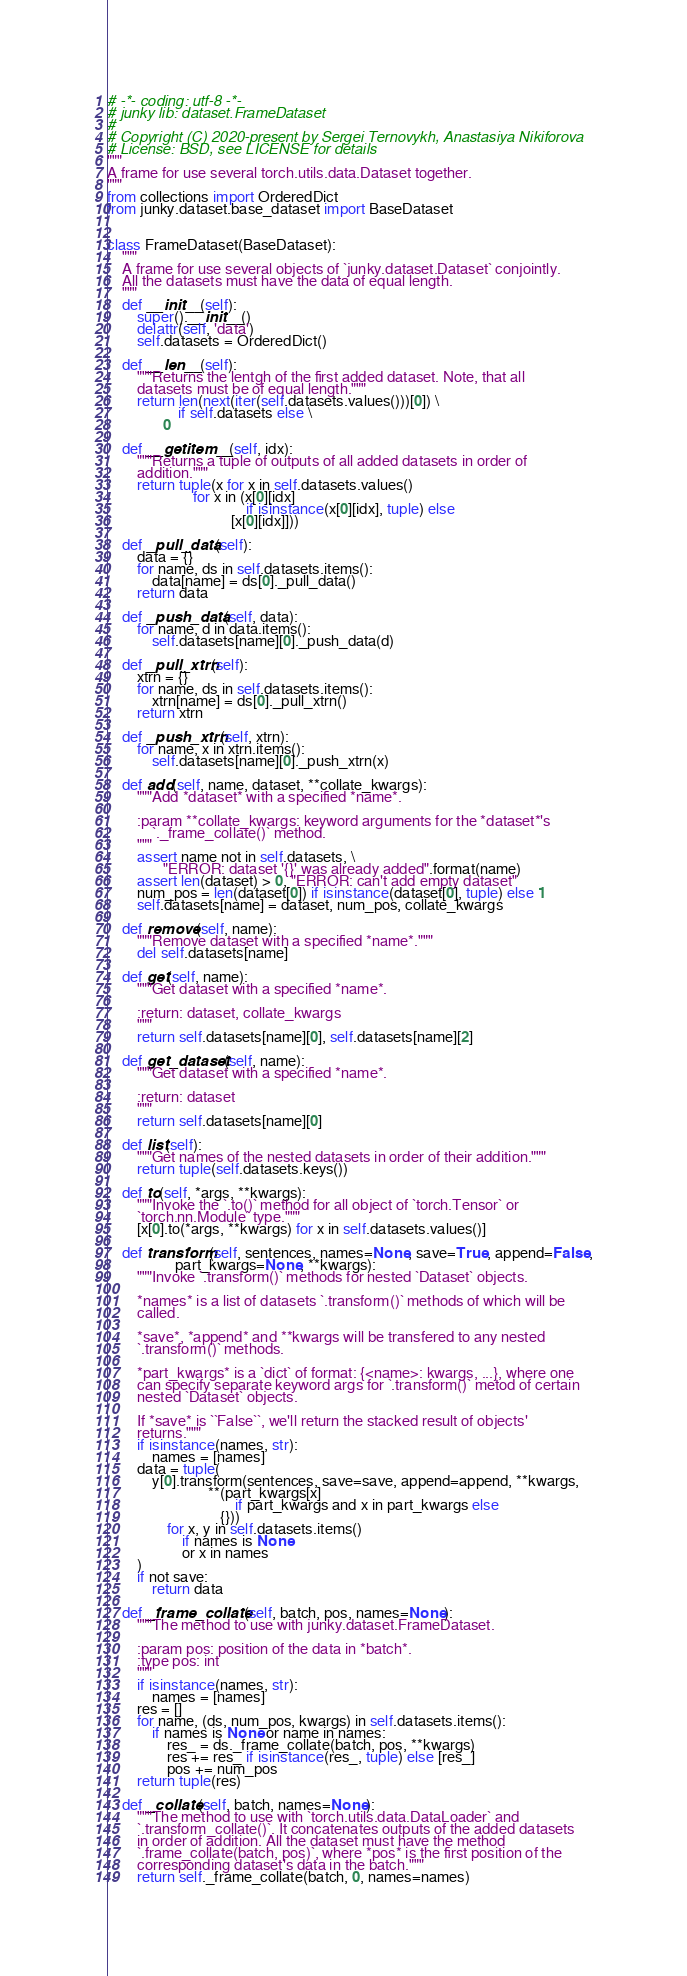<code> <loc_0><loc_0><loc_500><loc_500><_Python_># -*- coding: utf-8 -*-
# junky lib: dataset.FrameDataset
#
# Copyright (C) 2020-present by Sergei Ternovykh, Anastasiya Nikiforova
# License: BSD, see LICENSE for details
"""
A frame for use several torch.utils.data.Dataset together.
"""
from collections import OrderedDict
from junky.dataset.base_dataset import BaseDataset


class FrameDataset(BaseDataset):
    """
    A frame for use several objects of `junky.dataset.Dataset` conjointly.
    All the datasets must have the data of equal length.
    """
    def __init__(self):
        super().__init__()
        delattr(self, 'data')
        self.datasets = OrderedDict()

    def __len__(self):
        """Returns the lentgh of the first added dataset. Note, that all
        datasets must be of equal length."""
        return len(next(iter(self.datasets.values()))[0]) \
                   if self.datasets else \
               0

    def __getitem__(self, idx):
        """Returns a tuple of outputs of all added datasets in order of
        addition."""
        return tuple(x for x in self.datasets.values()
                       for x in (x[0][idx]
                                     if isinstance(x[0][idx], tuple) else
                                 [x[0][idx]]))

    def _pull_data(self):
        data = {}
        for name, ds in self.datasets.items():
            data[name] = ds[0]._pull_data()
        return data

    def _push_data(self, data):
        for name, d in data.items():
            self.datasets[name][0]._push_data(d)

    def _pull_xtrn(self):
        xtrn = {}
        for name, ds in self.datasets.items():
            xtrn[name] = ds[0]._pull_xtrn()
        return xtrn

    def _push_xtrn(self, xtrn):
        for name, x in xtrn.items():
            self.datasets[name][0]._push_xtrn(x)

    def add(self, name, dataset, **collate_kwargs):
        """Add *dataset* with a specified *name*.

        :param **collate_kwargs: keyword arguments for the *dataset*'s
            `._frame_collate()` method.
        """
        assert name not in self.datasets, \
               "ERROR: dataset '{}' was already added".format(name)
        assert len(dataset) > 0, "ERROR: can't add empty dataset"
        num_pos = len(dataset[0]) if isinstance(dataset[0], tuple) else 1
        self.datasets[name] = dataset, num_pos, collate_kwargs

    def remove(self, name):
        """Remove dataset with a specified *name*."""
        del self.datasets[name]

    def get(self, name):
        """Get dataset with a specified *name*.

        :return: dataset, collate_kwargs
        """
        return self.datasets[name][0], self.datasets[name][2]

    def get_dataset(self, name):
        """Get dataset with a specified *name*.

        :return: dataset
        """
        return self.datasets[name][0]

    def list(self):
        """Get names of the nested datasets in order of their addition."""
        return tuple(self.datasets.keys())

    def to(self, *args, **kwargs):
        """Invoke the `.to()` method for all object of `torch.Tensor` or
        `torch.nn.Module` type."""
        [x[0].to(*args, **kwargs) for x in self.datasets.values()]

    def transform(self, sentences, names=None, save=True, append=False,
                  part_kwargs=None, **kwargs):
        """Invoke `.transform()` methods for nested `Dataset` objects.

        *names* is a list of datasets `.transform()` methods of which will be
        called.

        *save*, *append* and **kwargs will be transfered to any nested
        `.transform()` methods.

        *part_kwargs* is a `dict` of format: {<name>: kwargs, ...}, where one
        can specify separate keyword args for `.transform()` metod of certain
        nested `Dataset` objects.

        If *save* is ``False``, we'll return the stacked result of objects'
        returns."""
        if isinstance(names, str):
            names = [names]
        data = tuple(
            y[0].transform(sentences, save=save, append=append, **kwargs,
                           **(part_kwargs[x]
                                  if part_kwargs and x in part_kwargs else
                              {}))
                for x, y in self.datasets.items()
                    if names is None
                    or x in names
        )
        if not save:
            return data

    def _frame_collate(self, batch, pos, names=None):
        """The method to use with junky.dataset.FrameDataset.

        :param pos: position of the data in *batch*.
        :type pos: int
        """
        if isinstance(names, str):
            names = [names]
        res = []
        for name, (ds, num_pos, kwargs) in self.datasets.items():
            if names is None or name in names:
                res_ = ds._frame_collate(batch, pos, **kwargs)
                res += res_ if isinstance(res_, tuple) else [res_]
                pos += num_pos
        return tuple(res)

    def _collate(self, batch, names=None):
        """The method to use with `torch.utils.data.DataLoader` and
        `.transform_collate()`. It concatenates outputs of the added datasets
        in order of addition. All the dataset must have the method
        `.frame_collate(batch, pos)`, where *pos* is the first position of the
        corresponding dataset's data in the batch."""
        return self._frame_collate(batch, 0, names=names)
</code> 